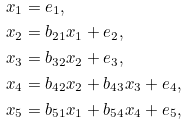Convert formula to latex. <formula><loc_0><loc_0><loc_500><loc_500>x _ { 1 } & = e _ { 1 } , \\ x _ { 2 } & = b _ { 2 1 } x _ { 1 } + e _ { 2 } , \\ x _ { 3 } & = b _ { 3 2 } x _ { 2 } + e _ { 3 } , \\ x _ { 4 } & = b _ { 4 2 } x _ { 2 } + b _ { 4 3 } x _ { 3 } + e _ { 4 } , \\ x _ { 5 } & = b _ { 5 1 } x _ { 1 } + b _ { 5 4 } x _ { 4 } + e _ { 5 } ,</formula> 